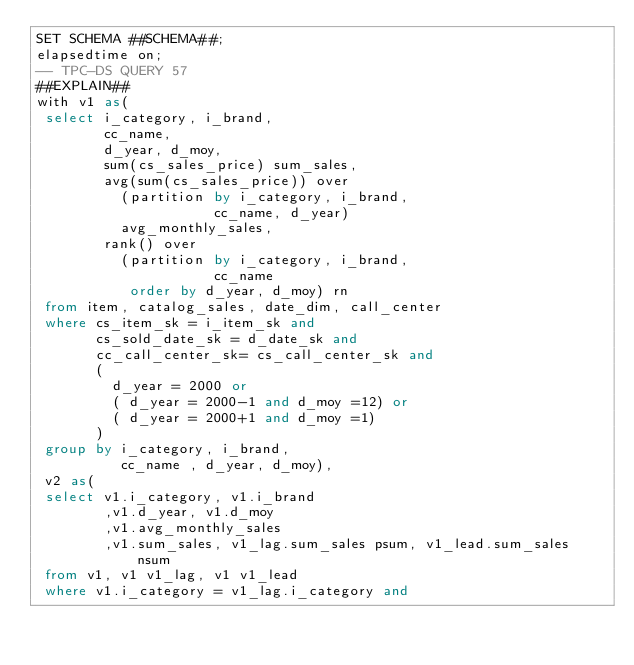<code> <loc_0><loc_0><loc_500><loc_500><_SQL_>SET SCHEMA ##SCHEMA##;
elapsedtime on;
-- TPC-DS QUERY 57
##EXPLAIN##
with v1 as(
 select i_category, i_brand,
        cc_name,
        d_year, d_moy,
        sum(cs_sales_price) sum_sales,
        avg(sum(cs_sales_price)) over
          (partition by i_category, i_brand,
                     cc_name, d_year)
          avg_monthly_sales,
        rank() over
          (partition by i_category, i_brand,
                     cc_name
           order by d_year, d_moy) rn
 from item, catalog_sales, date_dim, call_center
 where cs_item_sk = i_item_sk and
       cs_sold_date_sk = d_date_sk and
       cc_call_center_sk= cs_call_center_sk and
       (
         d_year = 2000 or
         ( d_year = 2000-1 and d_moy =12) or
         ( d_year = 2000+1 and d_moy =1)
       )
 group by i_category, i_brand,
          cc_name , d_year, d_moy),
 v2 as(
 select v1.i_category, v1.i_brand
        ,v1.d_year, v1.d_moy
        ,v1.avg_monthly_sales
        ,v1.sum_sales, v1_lag.sum_sales psum, v1_lead.sum_sales nsum
 from v1, v1 v1_lag, v1 v1_lead
 where v1.i_category = v1_lag.i_category and</code> 